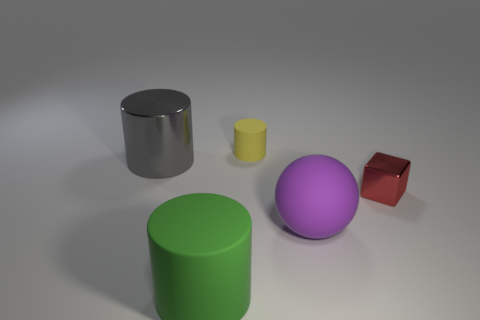How many other objects are there of the same shape as the red thing?
Provide a succinct answer. 0. Is the number of large green matte things left of the green rubber cylinder less than the number of rubber balls behind the big gray shiny cylinder?
Your response must be concise. No. Is the big gray cylinder made of the same material as the large object in front of the big purple sphere?
Offer a terse response. No. Are there any other things that have the same material as the tiny red object?
Keep it short and to the point. Yes. Are there more red cylinders than green cylinders?
Provide a short and direct response. No. There is a big matte object that is on the right side of the matte cylinder in front of the metallic object that is to the left of the green rubber cylinder; what is its shape?
Provide a short and direct response. Sphere. Is the tiny thing that is behind the red cube made of the same material as the big object behind the large purple rubber ball?
Provide a short and direct response. No. What is the shape of the small thing that is the same material as the large gray cylinder?
Your answer should be compact. Cube. Is there any other thing that has the same color as the shiny cylinder?
Offer a terse response. No. What number of small yellow matte things are there?
Provide a succinct answer. 1. 